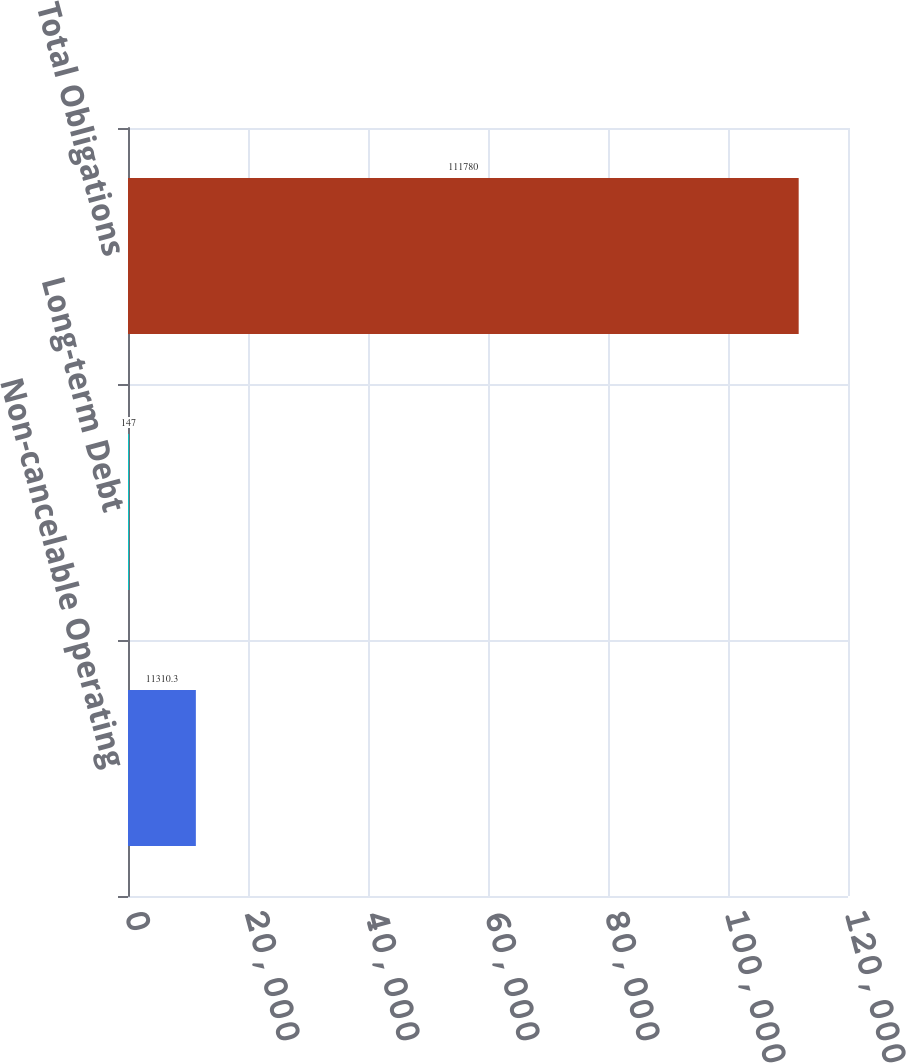Convert chart. <chart><loc_0><loc_0><loc_500><loc_500><bar_chart><fcel>Non-cancelable Operating<fcel>Long-term Debt<fcel>Total Obligations<nl><fcel>11310.3<fcel>147<fcel>111780<nl></chart> 